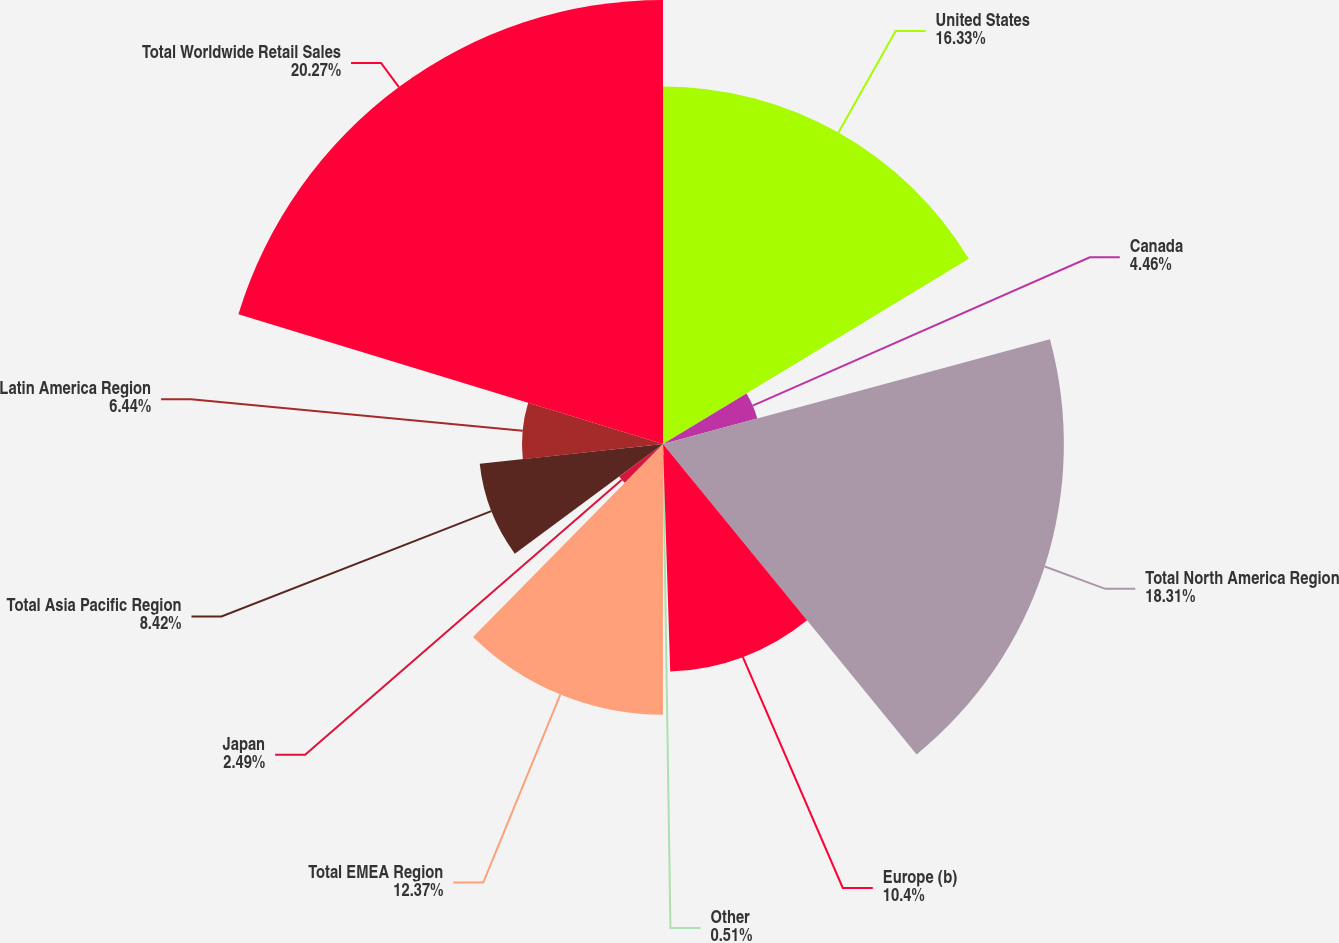Convert chart. <chart><loc_0><loc_0><loc_500><loc_500><pie_chart><fcel>United States<fcel>Canada<fcel>Total North America Region<fcel>Europe (b)<fcel>Other<fcel>Total EMEA Region<fcel>Japan<fcel>Total Asia Pacific Region<fcel>Latin America Region<fcel>Total Worldwide Retail Sales<nl><fcel>16.33%<fcel>4.46%<fcel>18.31%<fcel>10.4%<fcel>0.51%<fcel>12.37%<fcel>2.49%<fcel>8.42%<fcel>6.44%<fcel>20.28%<nl></chart> 